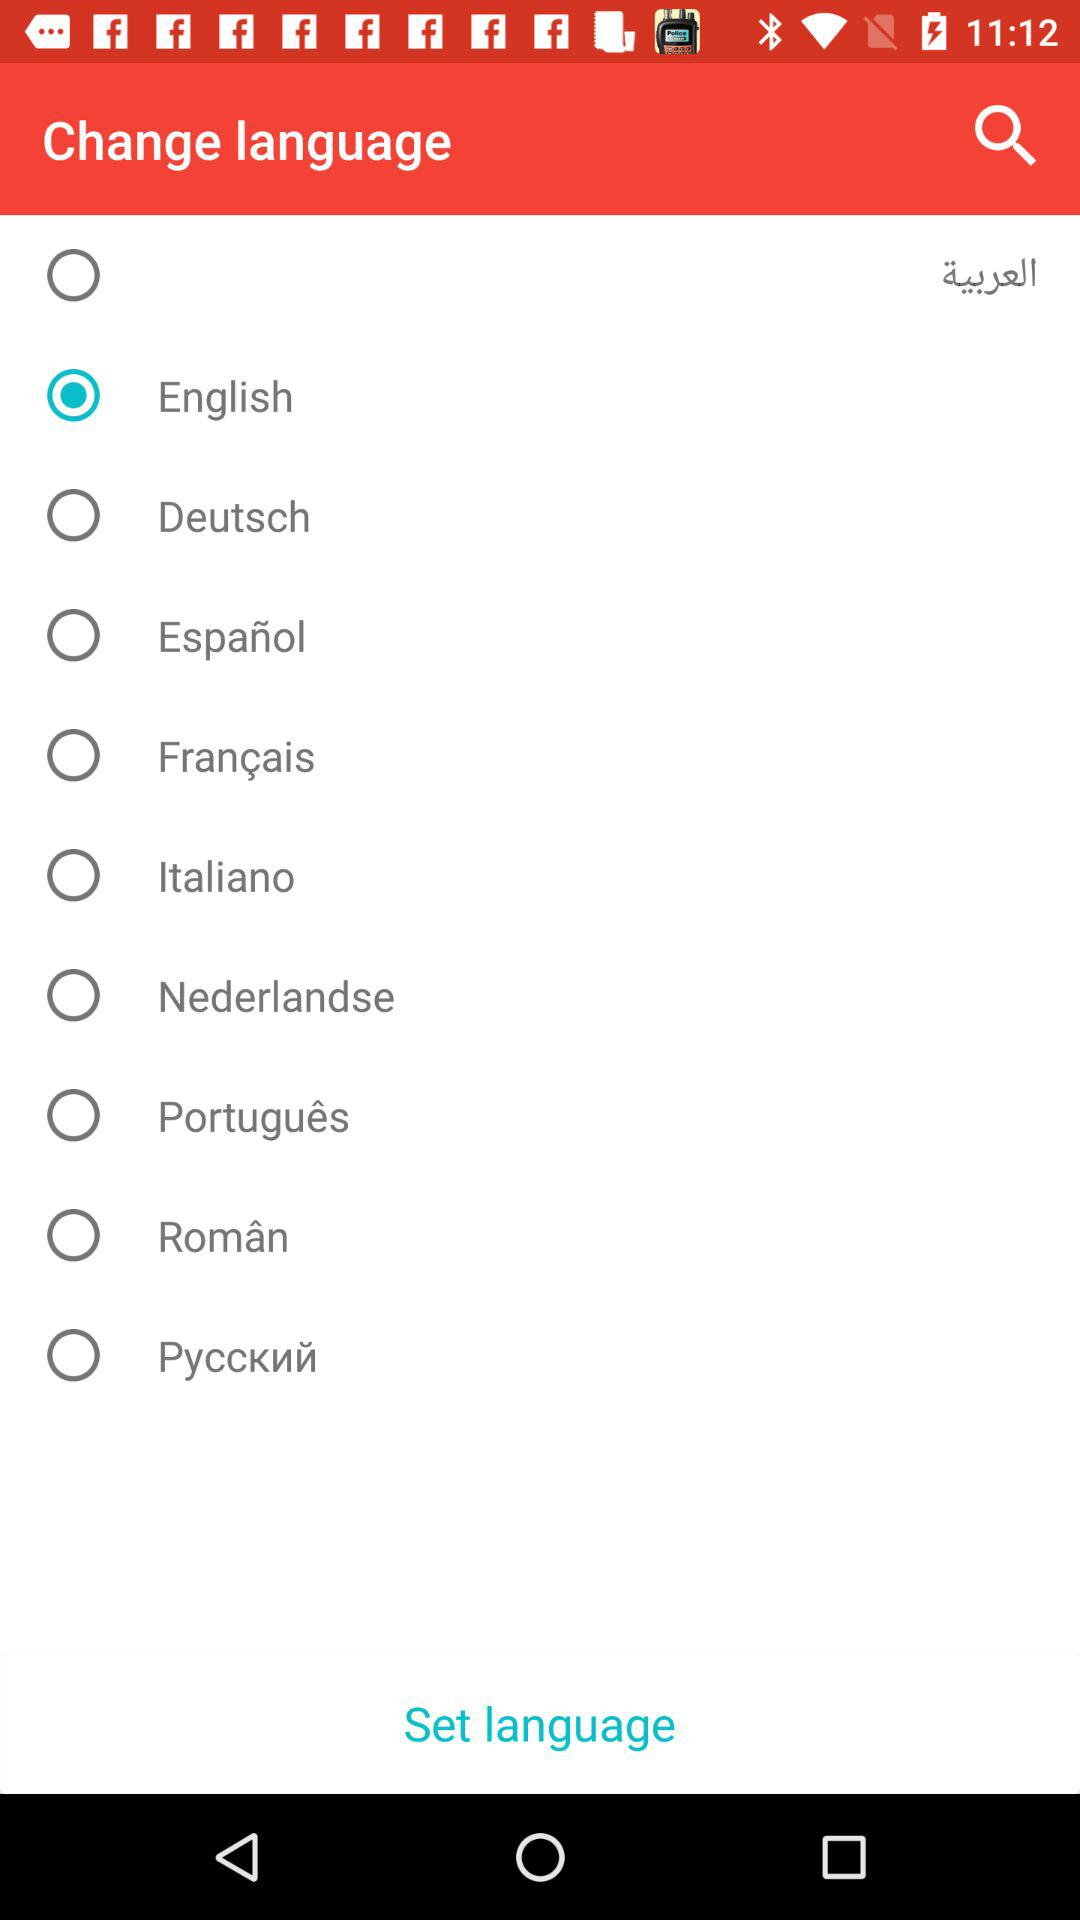What is the selected language? The selected language is English. 